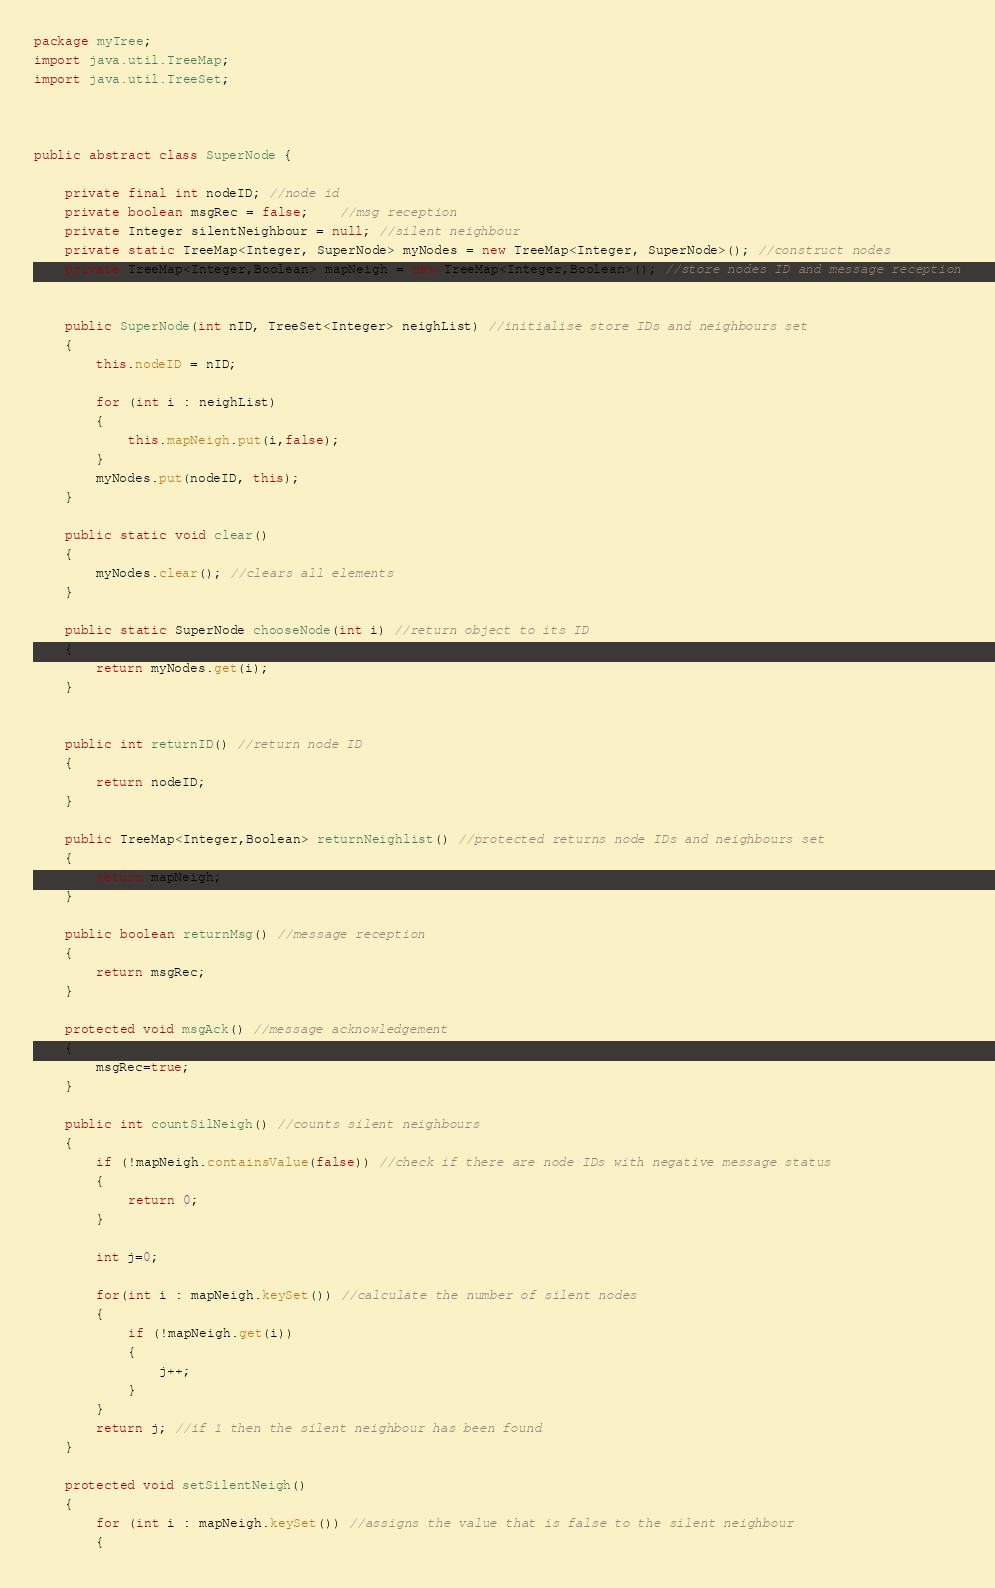Convert code to text. <code><loc_0><loc_0><loc_500><loc_500><_Java_>package myTree;
import java.util.TreeMap;
import java.util.TreeSet;


            
public abstract class SuperNode {
	
	private final int nodeID; //node id
	private boolean msgRec = false;	//msg reception
	private Integer silentNeighbour = null; //silent neighbour
	private static TreeMap<Integer, SuperNode> myNodes = new TreeMap<Integer, SuperNode>(); //construct nodes
	private TreeMap<Integer,Boolean> mapNeigh = new TreeMap<Integer,Boolean>(); //store nodes ID and message reception
	
	                  
	public SuperNode(int nID, TreeSet<Integer> neighList) //initialise store IDs and neighbours set
	{                	  
		this.nodeID = nID;
		
		for (int i : neighList)
		{
			this.mapNeigh.put(i,false);
		}
		myNodes.put(nodeID, this);
	}
	
	public static void clear()
	{
		myNodes.clear(); //clears all elements
	}
	
	public static SuperNode chooseNode(int i) //return object to its ID
	{
		return myNodes.get(i);
	}
	
	
	public int returnID() //return node ID
	{
		return nodeID;
	}
	
	public TreeMap<Integer,Boolean> returnNeighlist() //protected returns node IDs and neighbours set
	{
		return mapNeigh;
	}
	
	public boolean returnMsg() //message reception
	{
		return msgRec;
	}
	
	protected void msgAck() //message acknowledgement
	{
		msgRec=true;
	}

	public int countSilNeigh() //counts silent neighbours
	{
		if (!mapNeigh.containsValue(false)) //check if there are node IDs with negative message status
		{
			return 0;
		}
		
		int j=0;
		
		for(int i : mapNeigh.keySet()) //calculate the number of silent nodes
		{
			if (!mapNeigh.get(i))
			{
				j++;
			}
		}
		return j; //if 1 then the silent neighbour has been found
	}
	
	protected void setSilentNeigh()
	{
		for (int i : mapNeigh.keySet()) //assigns the value that is false to the silent neighbour
		{</code> 